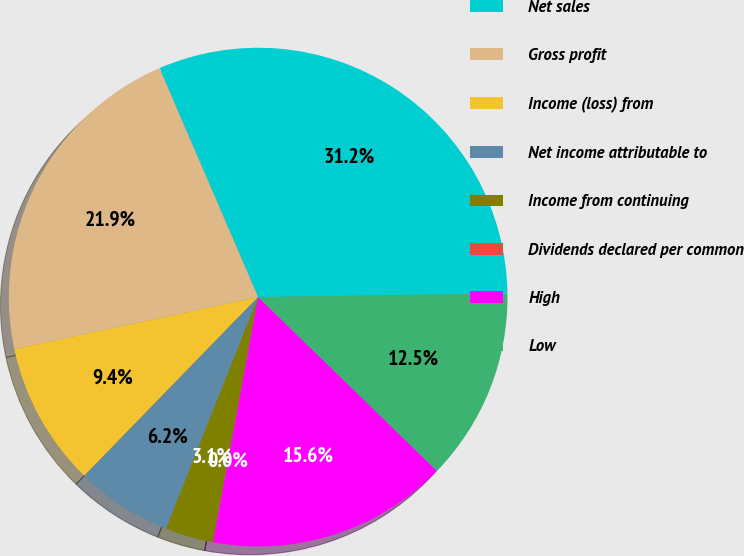Convert chart to OTSL. <chart><loc_0><loc_0><loc_500><loc_500><pie_chart><fcel>Net sales<fcel>Gross profit<fcel>Income (loss) from<fcel>Net income attributable to<fcel>Income from continuing<fcel>Dividends declared per common<fcel>High<fcel>Low<nl><fcel>31.25%<fcel>21.87%<fcel>9.38%<fcel>6.25%<fcel>3.13%<fcel>0.0%<fcel>15.62%<fcel>12.5%<nl></chart> 